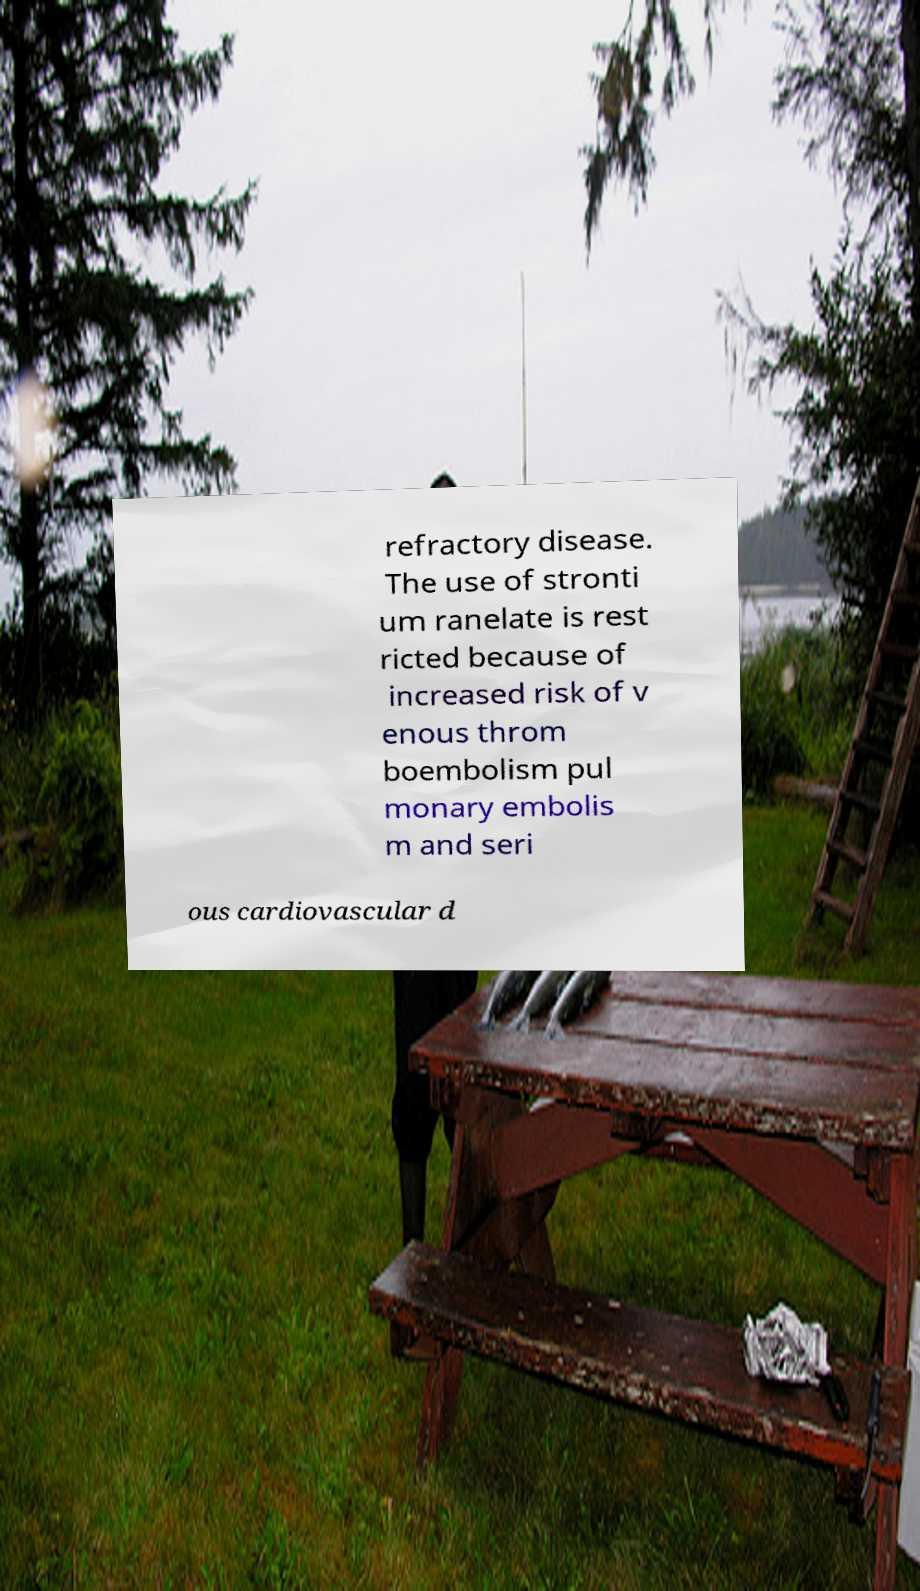Please identify and transcribe the text found in this image. refractory disease. The use of stronti um ranelate is rest ricted because of increased risk of v enous throm boembolism pul monary embolis m and seri ous cardiovascular d 